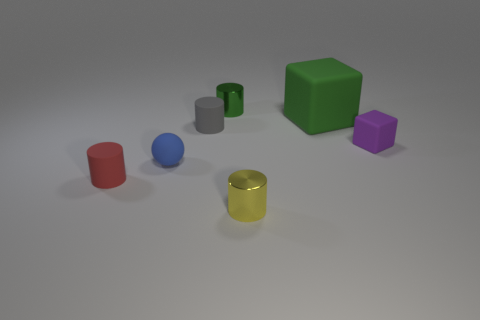Subtract all yellow cylinders. How many cylinders are left? 3 Add 1 tiny purple cubes. How many objects exist? 8 Subtract 1 cylinders. How many cylinders are left? 3 Subtract all green cylinders. How many cylinders are left? 3 Subtract 1 green cubes. How many objects are left? 6 Subtract all cubes. How many objects are left? 5 Subtract all gray cylinders. Subtract all purple balls. How many cylinders are left? 3 Subtract all red objects. Subtract all tiny metallic cylinders. How many objects are left? 4 Add 6 balls. How many balls are left? 7 Add 5 small green metallic cylinders. How many small green metallic cylinders exist? 6 